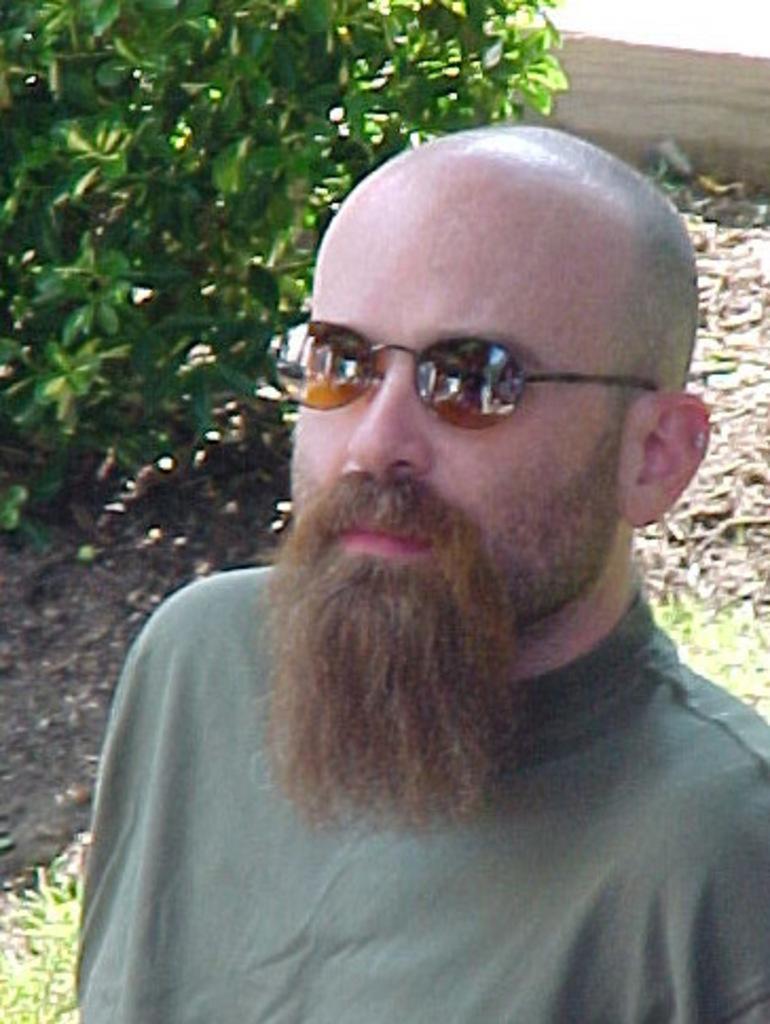Could you give a brief overview of what you see in this image? In this image we can see a person wearing glasses. In the background we can see a tree. 